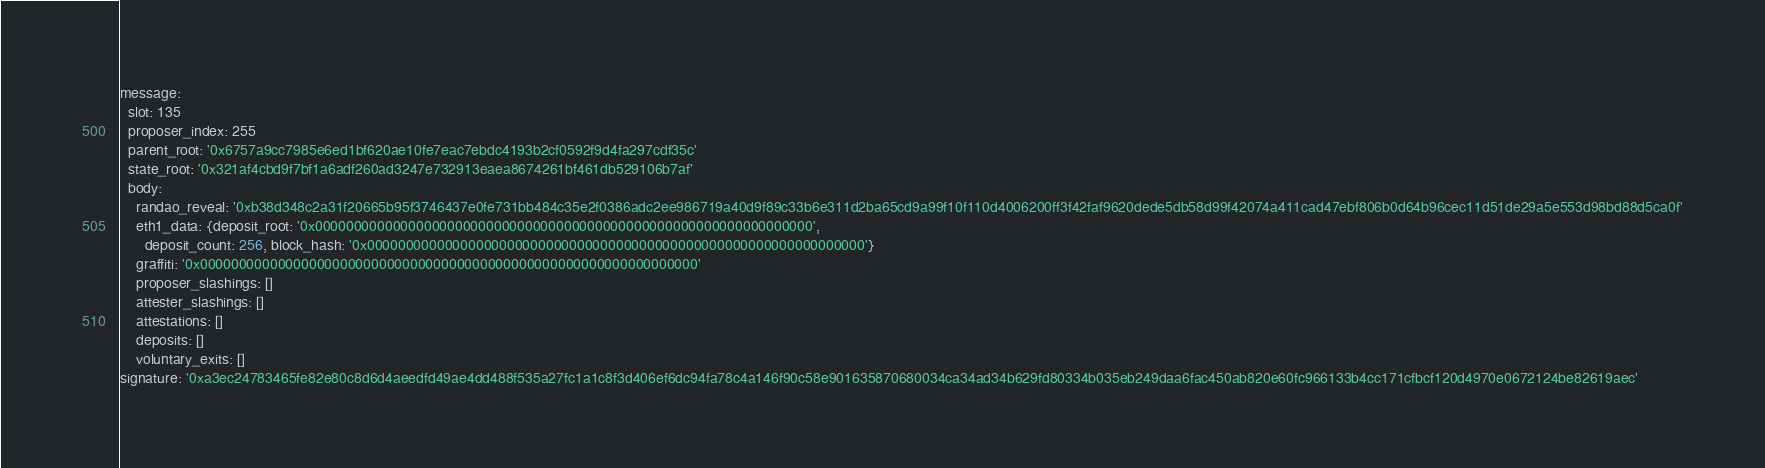<code> <loc_0><loc_0><loc_500><loc_500><_YAML_>message:
  slot: 135
  proposer_index: 255
  parent_root: '0x6757a9cc7985e6ed1bf620ae10fe7eac7ebdc4193b2cf0592f9d4fa297cdf35c'
  state_root: '0x321af4cbd9f7bf1a6adf260ad3247e732913eaea8674261bf461db529106b7af'
  body:
    randao_reveal: '0xb38d348c2a31f20665b95f3746437e0fe731bb484c35e2f0386adc2ee986719a40d9f89c33b6e311d2ba65cd9a99f10f110d4006200ff3f42faf9620dede5db58d99f42074a411cad47ebf806b0d64b96cec11d51de29a5e553d98bd88d5ca0f'
    eth1_data: {deposit_root: '0x0000000000000000000000000000000000000000000000000000000000000000',
      deposit_count: 256, block_hash: '0x0000000000000000000000000000000000000000000000000000000000000000'}
    graffiti: '0x0000000000000000000000000000000000000000000000000000000000000000'
    proposer_slashings: []
    attester_slashings: []
    attestations: []
    deposits: []
    voluntary_exits: []
signature: '0xa3ec24783465fe82e80c8d6d4aeedfd49ae4dd488f535a27fc1a1c8f3d406ef6dc94fa78c4a146f90c58e901635870680034ca34ad34b629fd80334b035eb249daa6fac450ab820e60fc966133b4cc171cfbcf120d4970e0672124be82619aec'
</code> 